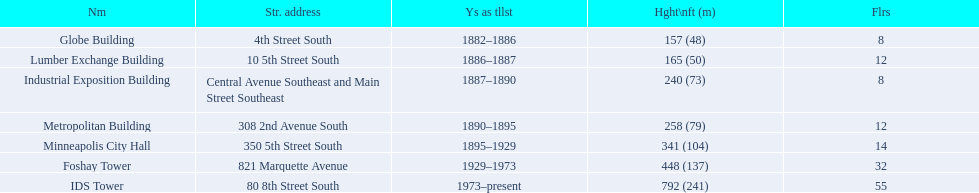Between the metropolitan building and the lumber exchange building, which one has a greater height? Metropolitan Building. 